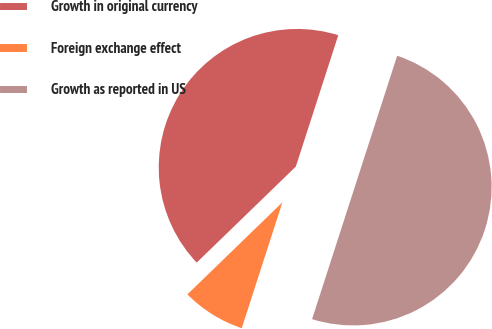Convert chart. <chart><loc_0><loc_0><loc_500><loc_500><pie_chart><fcel>Growth in original currency<fcel>Foreign exchange effect<fcel>Growth as reported in US<nl><fcel>42.22%<fcel>7.78%<fcel>50.0%<nl></chart> 